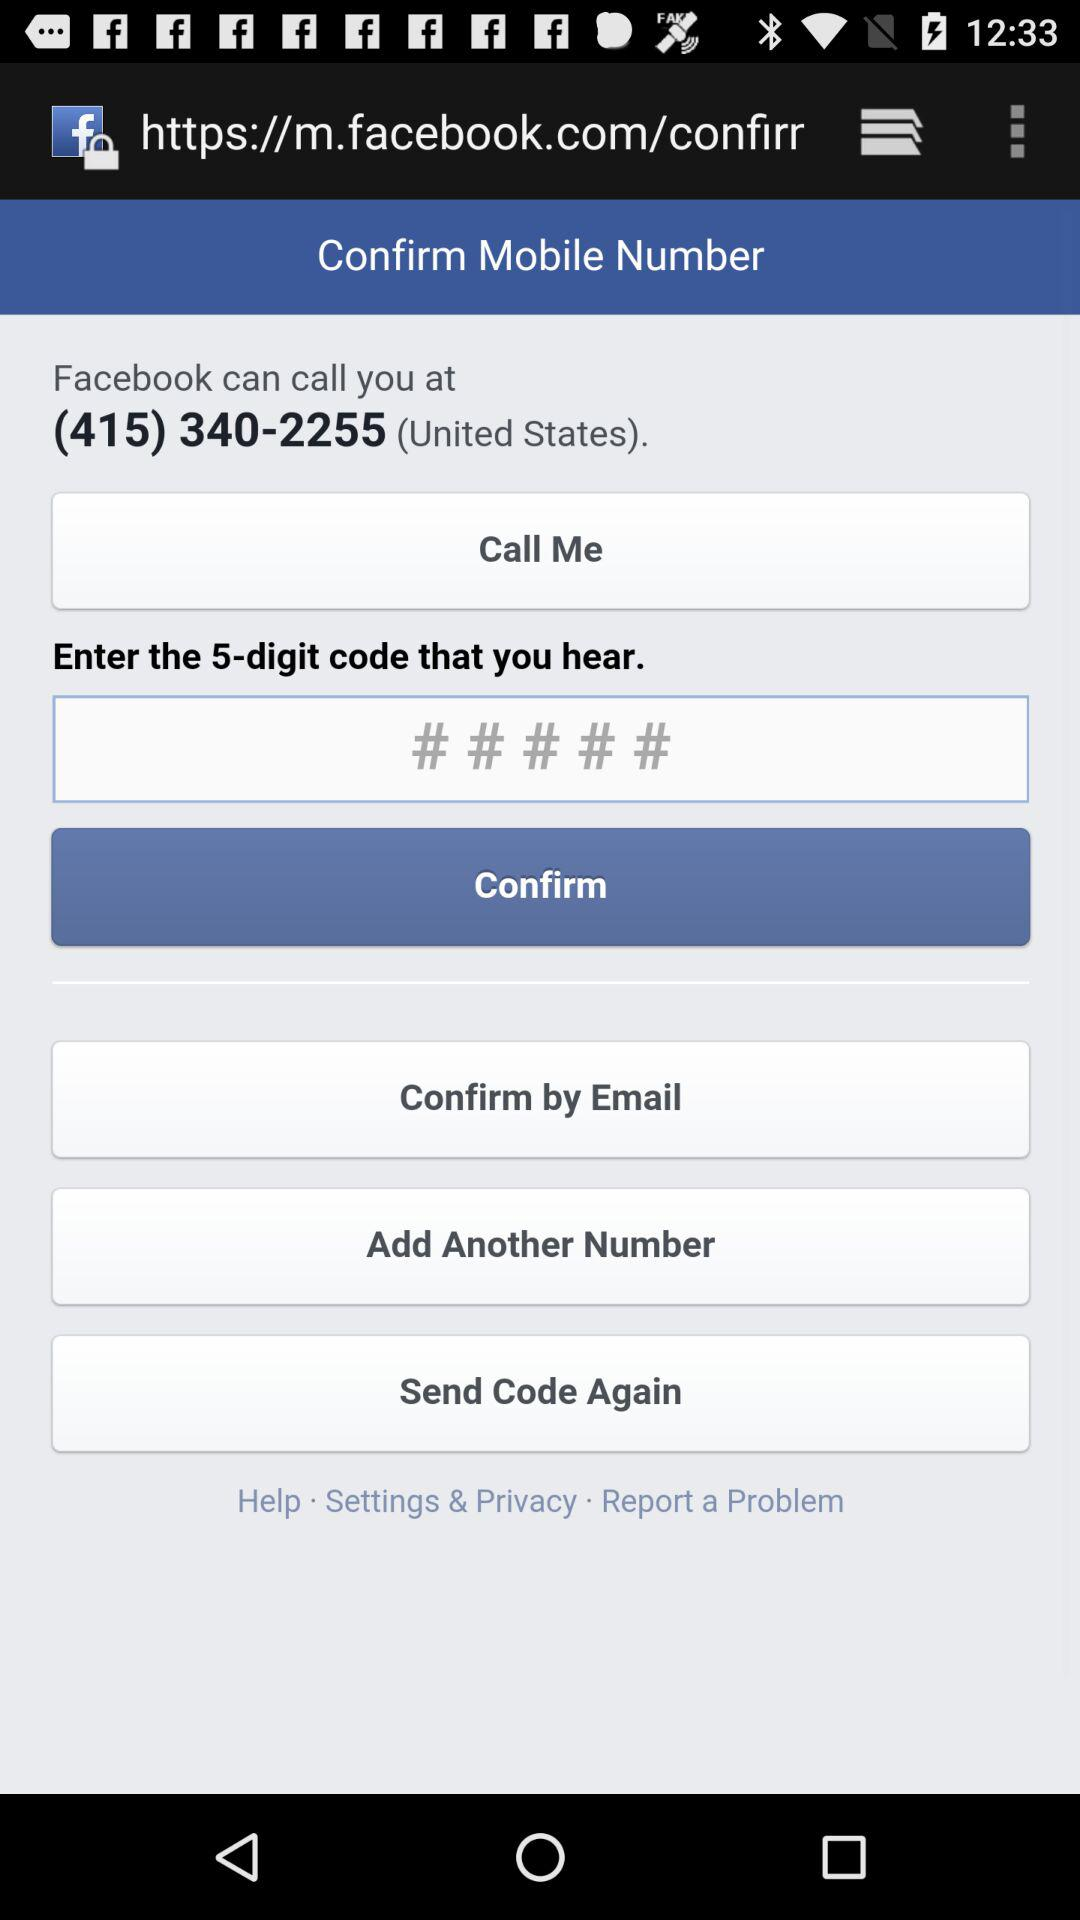How many numbers are in the 5-digit code?
Answer the question using a single word or phrase. 5 